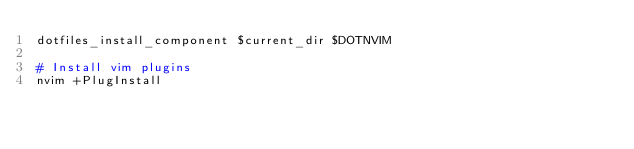<code> <loc_0><loc_0><loc_500><loc_500><_Bash_>dotfiles_install_component $current_dir $DOTNVIM

# Install vim plugins
nvim +PlugInstall
</code> 